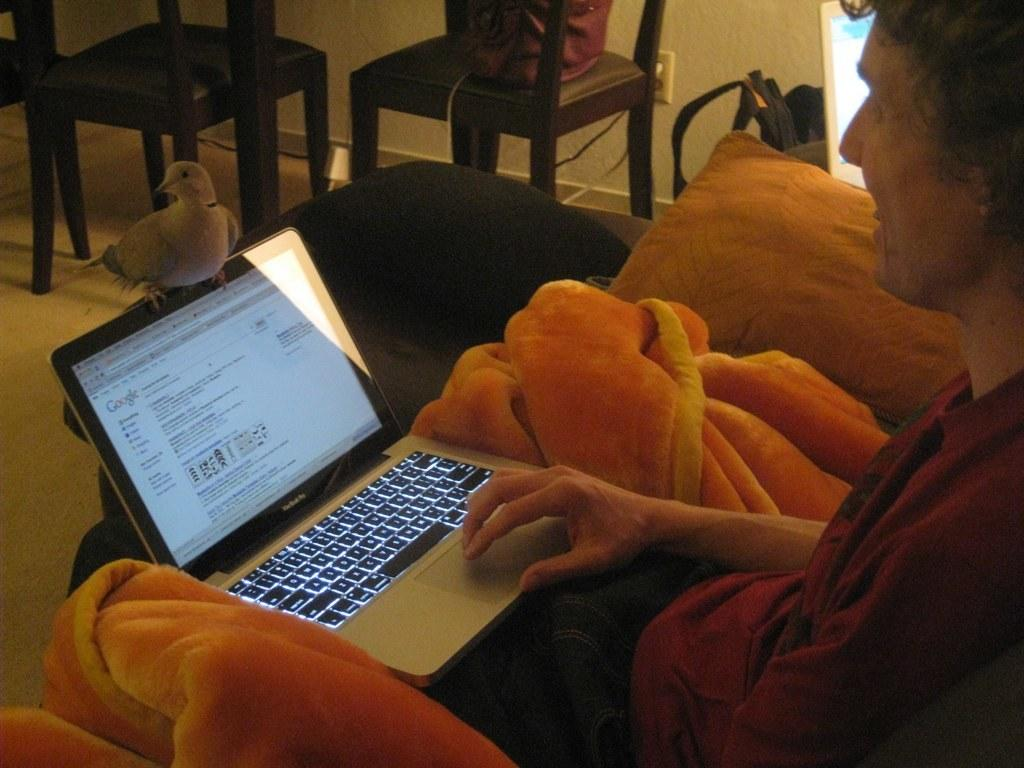What is the man in the image doing? The man is seated and holding a laptop in the image. What is on the laptop? There is a bird on the laptop. What type of furniture is visible in the image? Chairs are visible in the image. What type of accessory is present in the image? There is a pillow in the image. What type of mailbox is present in the image? There is no mailbox present in the image. What sense is the man using to interact with the bird on the laptop? The image does not provide information about the man's senses or how he is interacting with the bird on the laptop. 